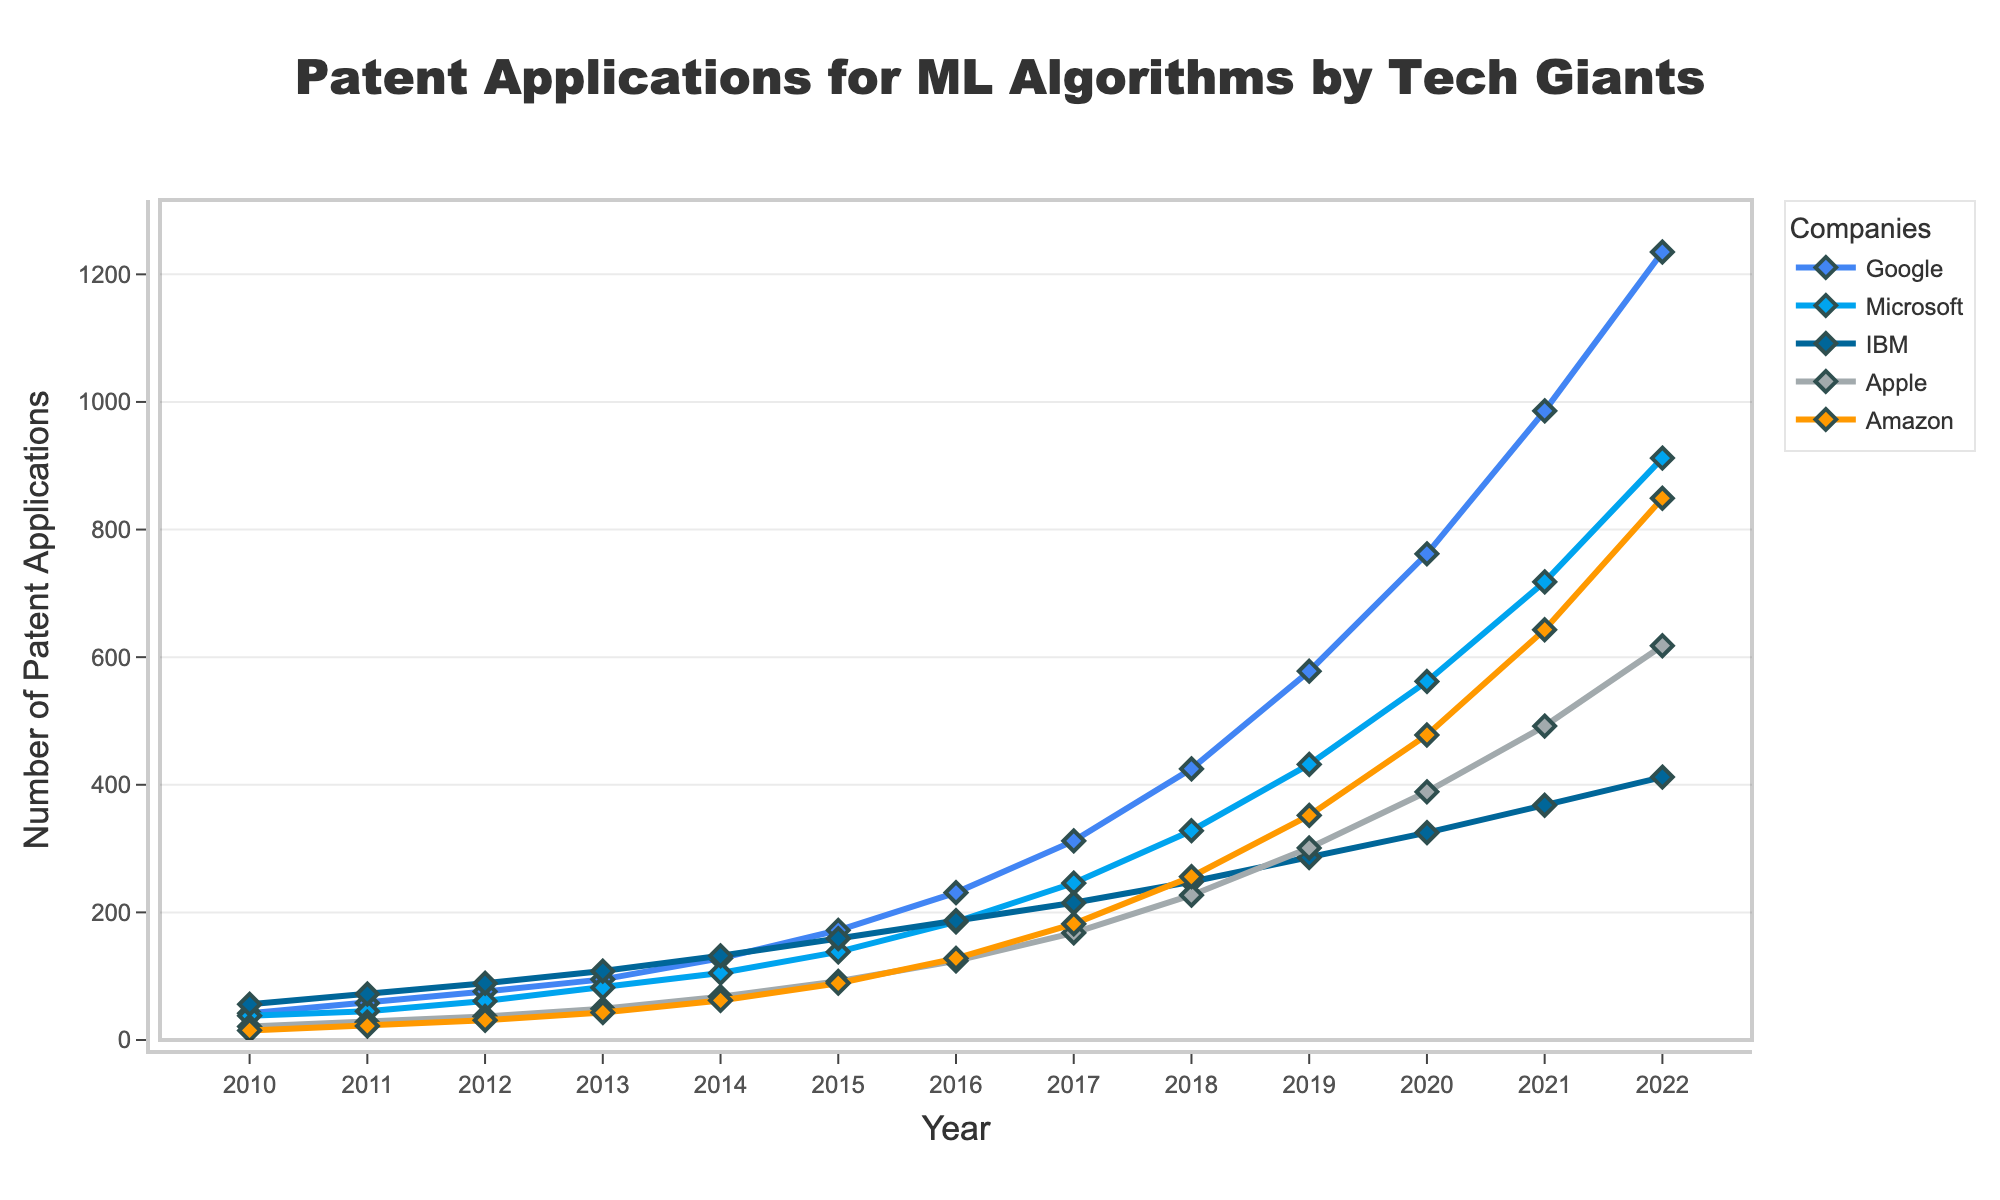What is the trend in the number of patent applications for machine learning algorithms by Google from 2010 to 2022? Google's patent applications increased consistently from 42 in 2010 to 1235 in 2022. This indicates a strong upward trend in Google's investment in machine learning algorithms over these years.
Answer: Consistent increase Which company had the highest number of patent applications in 2022? By checking the y-values for each company in 2022, Google had the highest number of patent applications at 1235.
Answer: Google Who had more patent applications in 2016, Microsoft or Amazon, and by how much? In 2016, Microsoft's applications were 185, and Amazon's were 128. The difference is 185 - 128 = 57. Therefore, Microsoft had 57 more patents than Amazon in 2016.
Answer: Microsoft by 57 Over which years did Apple see the greatest improvement in patent applications, and what was the increase? Checking the values for Apple, the biggest increase happened between 2016 (124) and 2017 (168), which is 168 - 124 = 44.
Answer: 2016 to 2017, 44 What was the average number of patent applications for IBM from 2010 to 2012? For IBM, sum the patent applications from 2010 (56), 2011 (72), and 2012 (89), then divide by the number of years. (56 + 72 + 89) / 3 = 217 / 3 = 72.33 (approx).
Answer: ~72.33 Comparing Google and Amazon, in which year did the difference in patent applications first exceed 300? Observing the trends, in 2019 Google's applications were 578 and Amazon's were 352. The difference is 578 - 352 = 226. In 2020, Google's were 762 and Amazon's were 478, a difference of 284. Finally, in 2021, Google's were 986 and Amazon's were 643, a difference of 343. Therefore, 2021 was the first year the difference exceeded 300.
Answer: 2021 What is the combined total number of patent applications for all companies in 2022? Sum the patent applications for each company in 2022: 1235 (Google) + 912 (Microsoft) + 412 (IBM) + 618 (Apple) + 849 (Amazon) = 4026.
Answer: 4026 In which year did IBM's number of patent applications first fall below the number in the previous year, and what were the patent counts for those years? IBM's decreasing trend first occurs from 2017 (215) to 2018 (248). The patent applications were 215 in 2017 and 248 in 2018.
Answer: 2017 to 2018 Which two companies had the closest number of patent applications in 2014 and what were their respective numbers? Checking the data for 2014, Microsoft had 105 patent applications, and IBM had 132 applications. Comparing the pairwise differences, the closest pair is Apple and Amazon with 68 and 62 applications respectively. The difference is 68 - 62 = 6.
Answer: Apple and Amazon; 68 and 62 